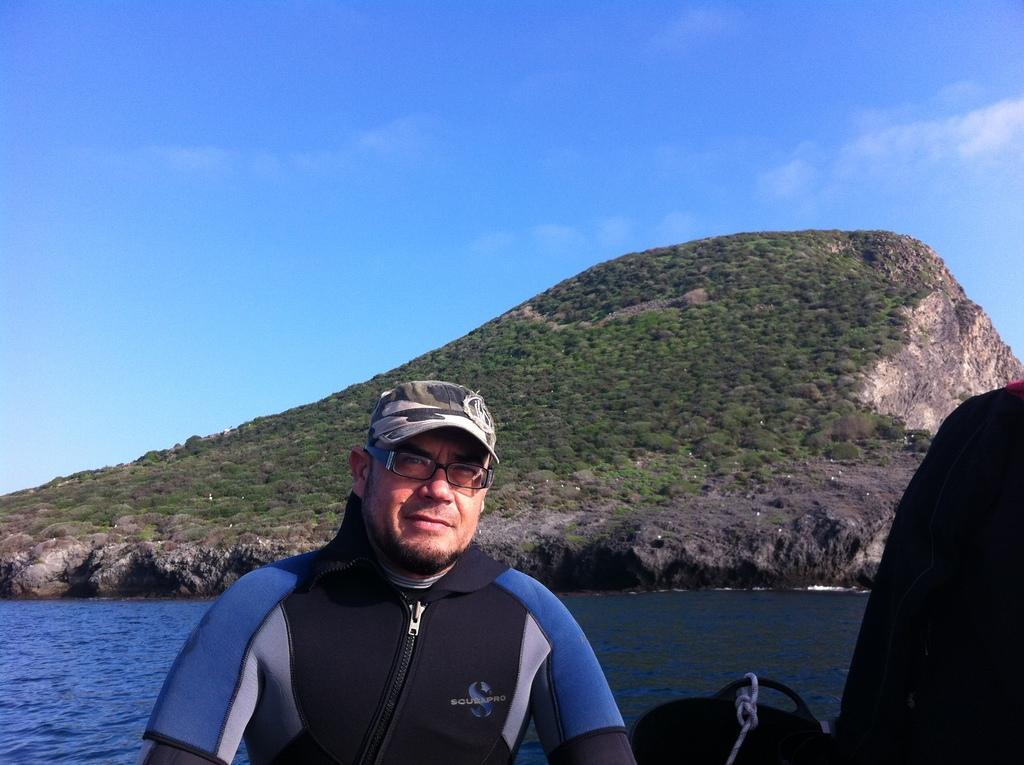Describe this image in one or two sentences. In this picture we can see a man in the front, he wore a cap and spectacles, there is water in the middle, in the background we can see a hill and plants, there is the sky at the top of the picture. 